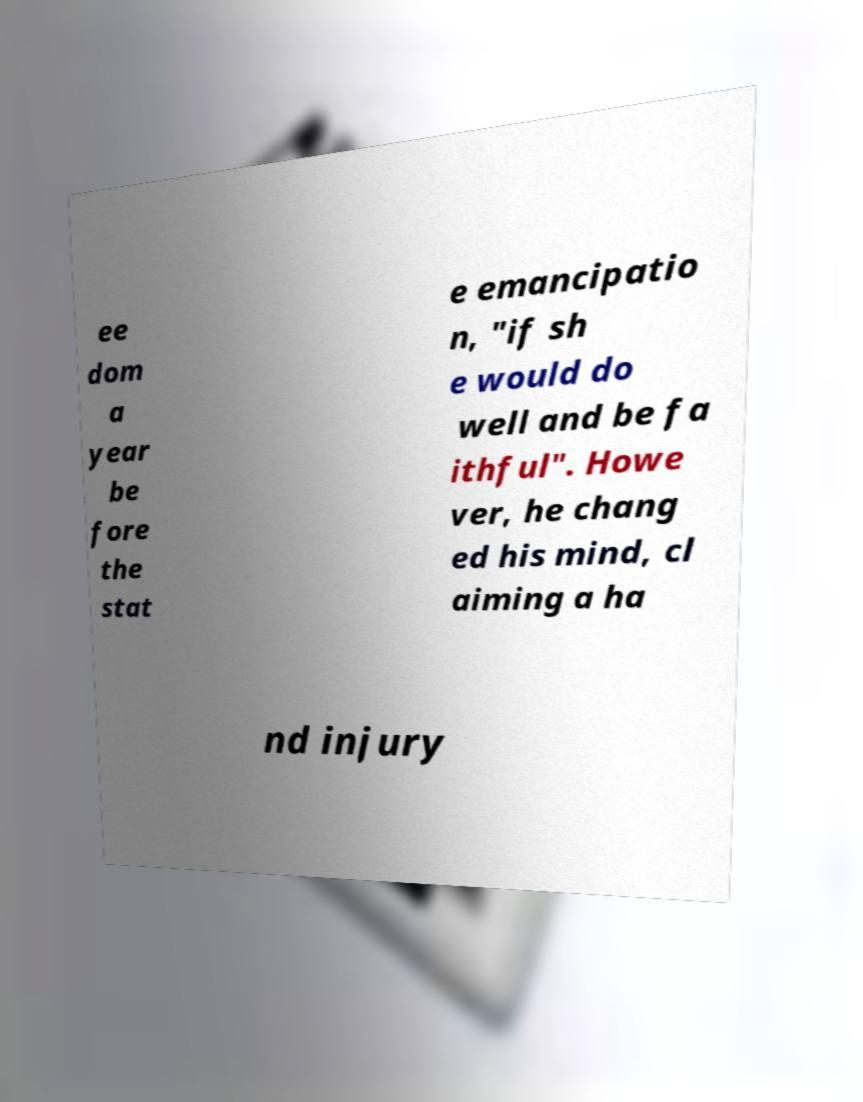There's text embedded in this image that I need extracted. Can you transcribe it verbatim? ee dom a year be fore the stat e emancipatio n, "if sh e would do well and be fa ithful". Howe ver, he chang ed his mind, cl aiming a ha nd injury 